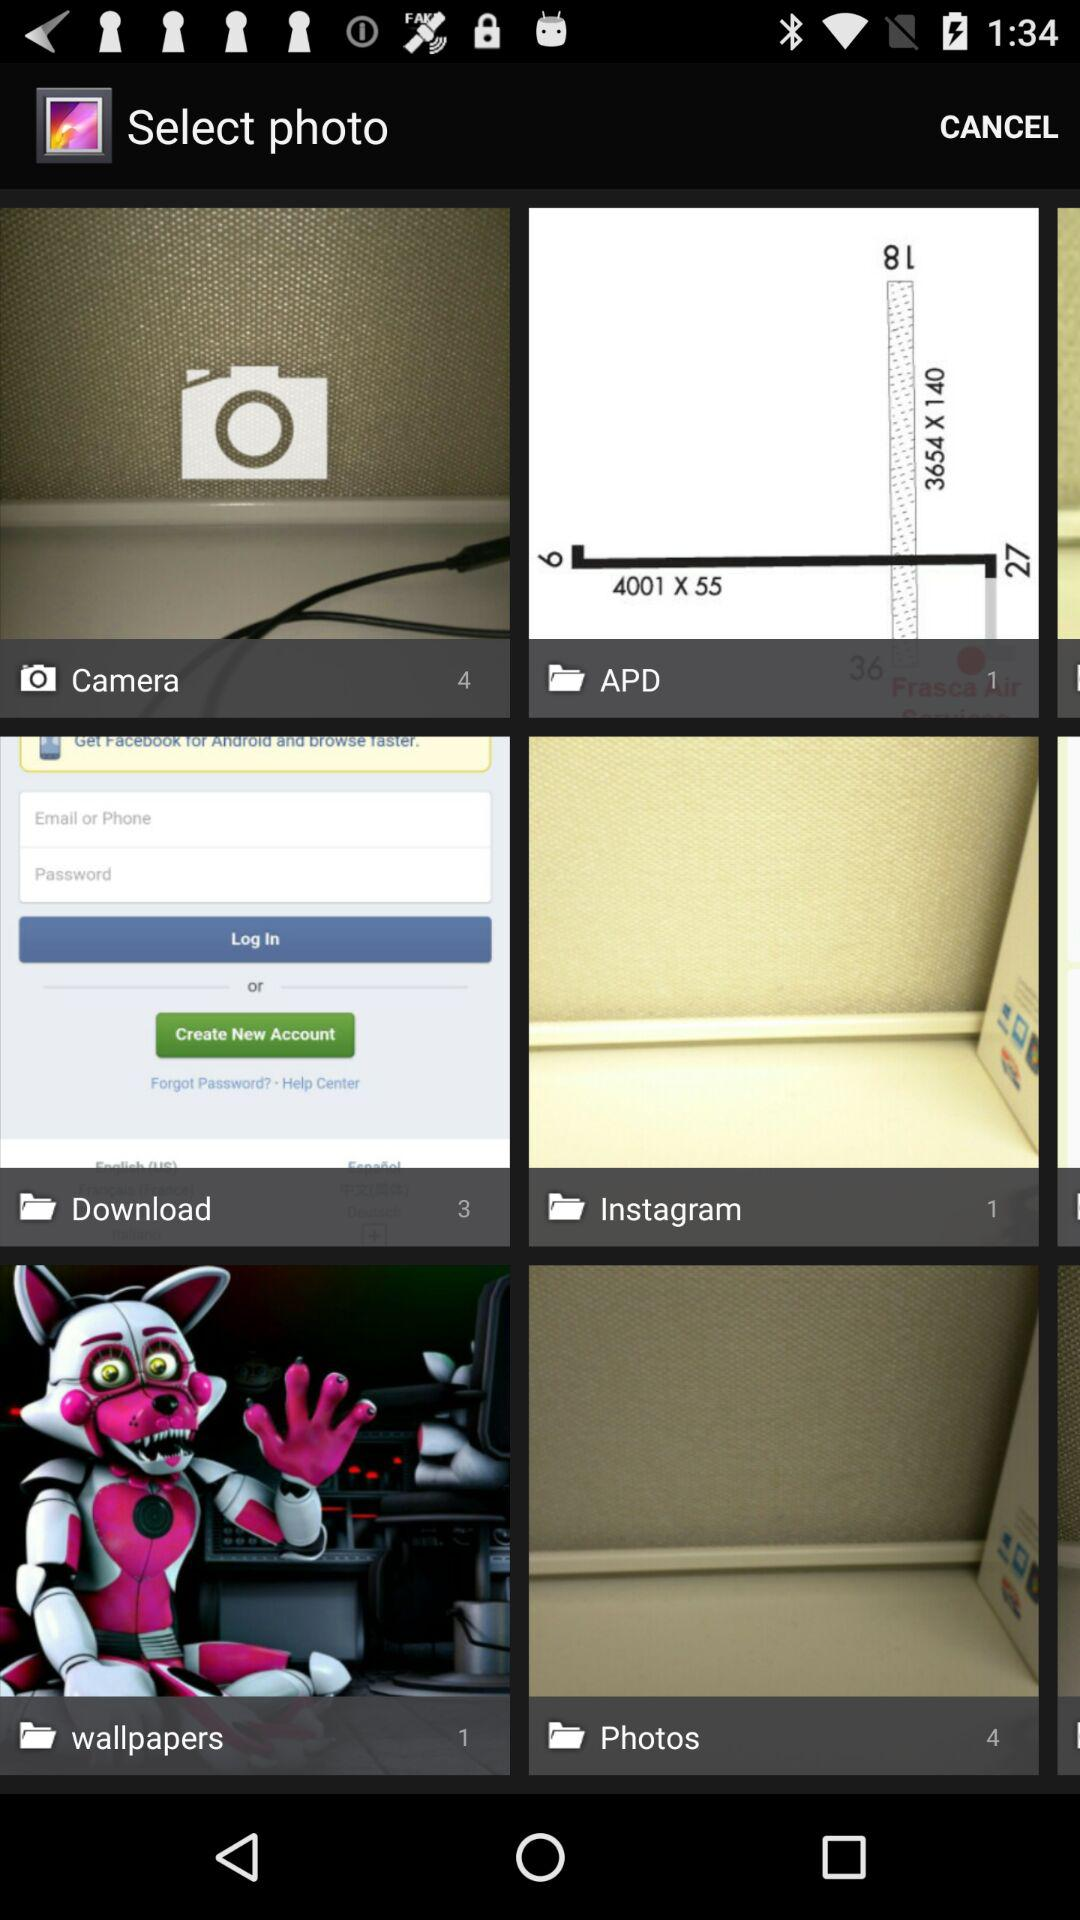What is the number of photos in "wallpapers"? The number of photos in "wallpapers" is 1. 